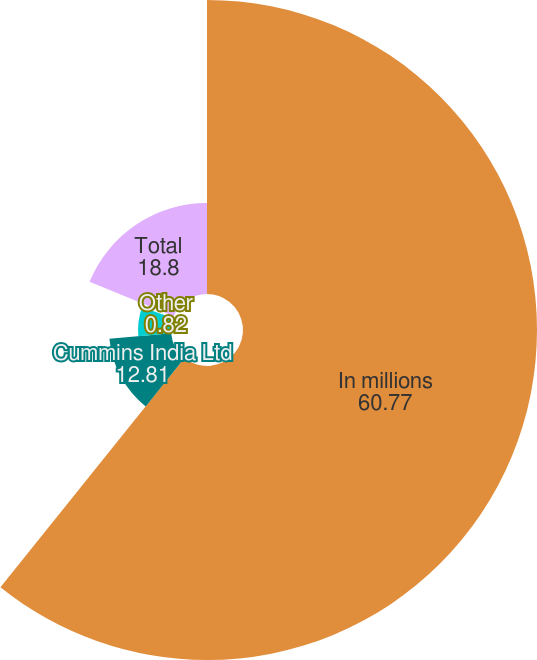Convert chart. <chart><loc_0><loc_0><loc_500><loc_500><pie_chart><fcel>In millions<fcel>Cummins India Ltd<fcel>Wuxi Cummins Turbo<fcel>Other<fcel>Total<nl><fcel>60.77%<fcel>12.81%<fcel>6.81%<fcel>0.82%<fcel>18.8%<nl></chart> 